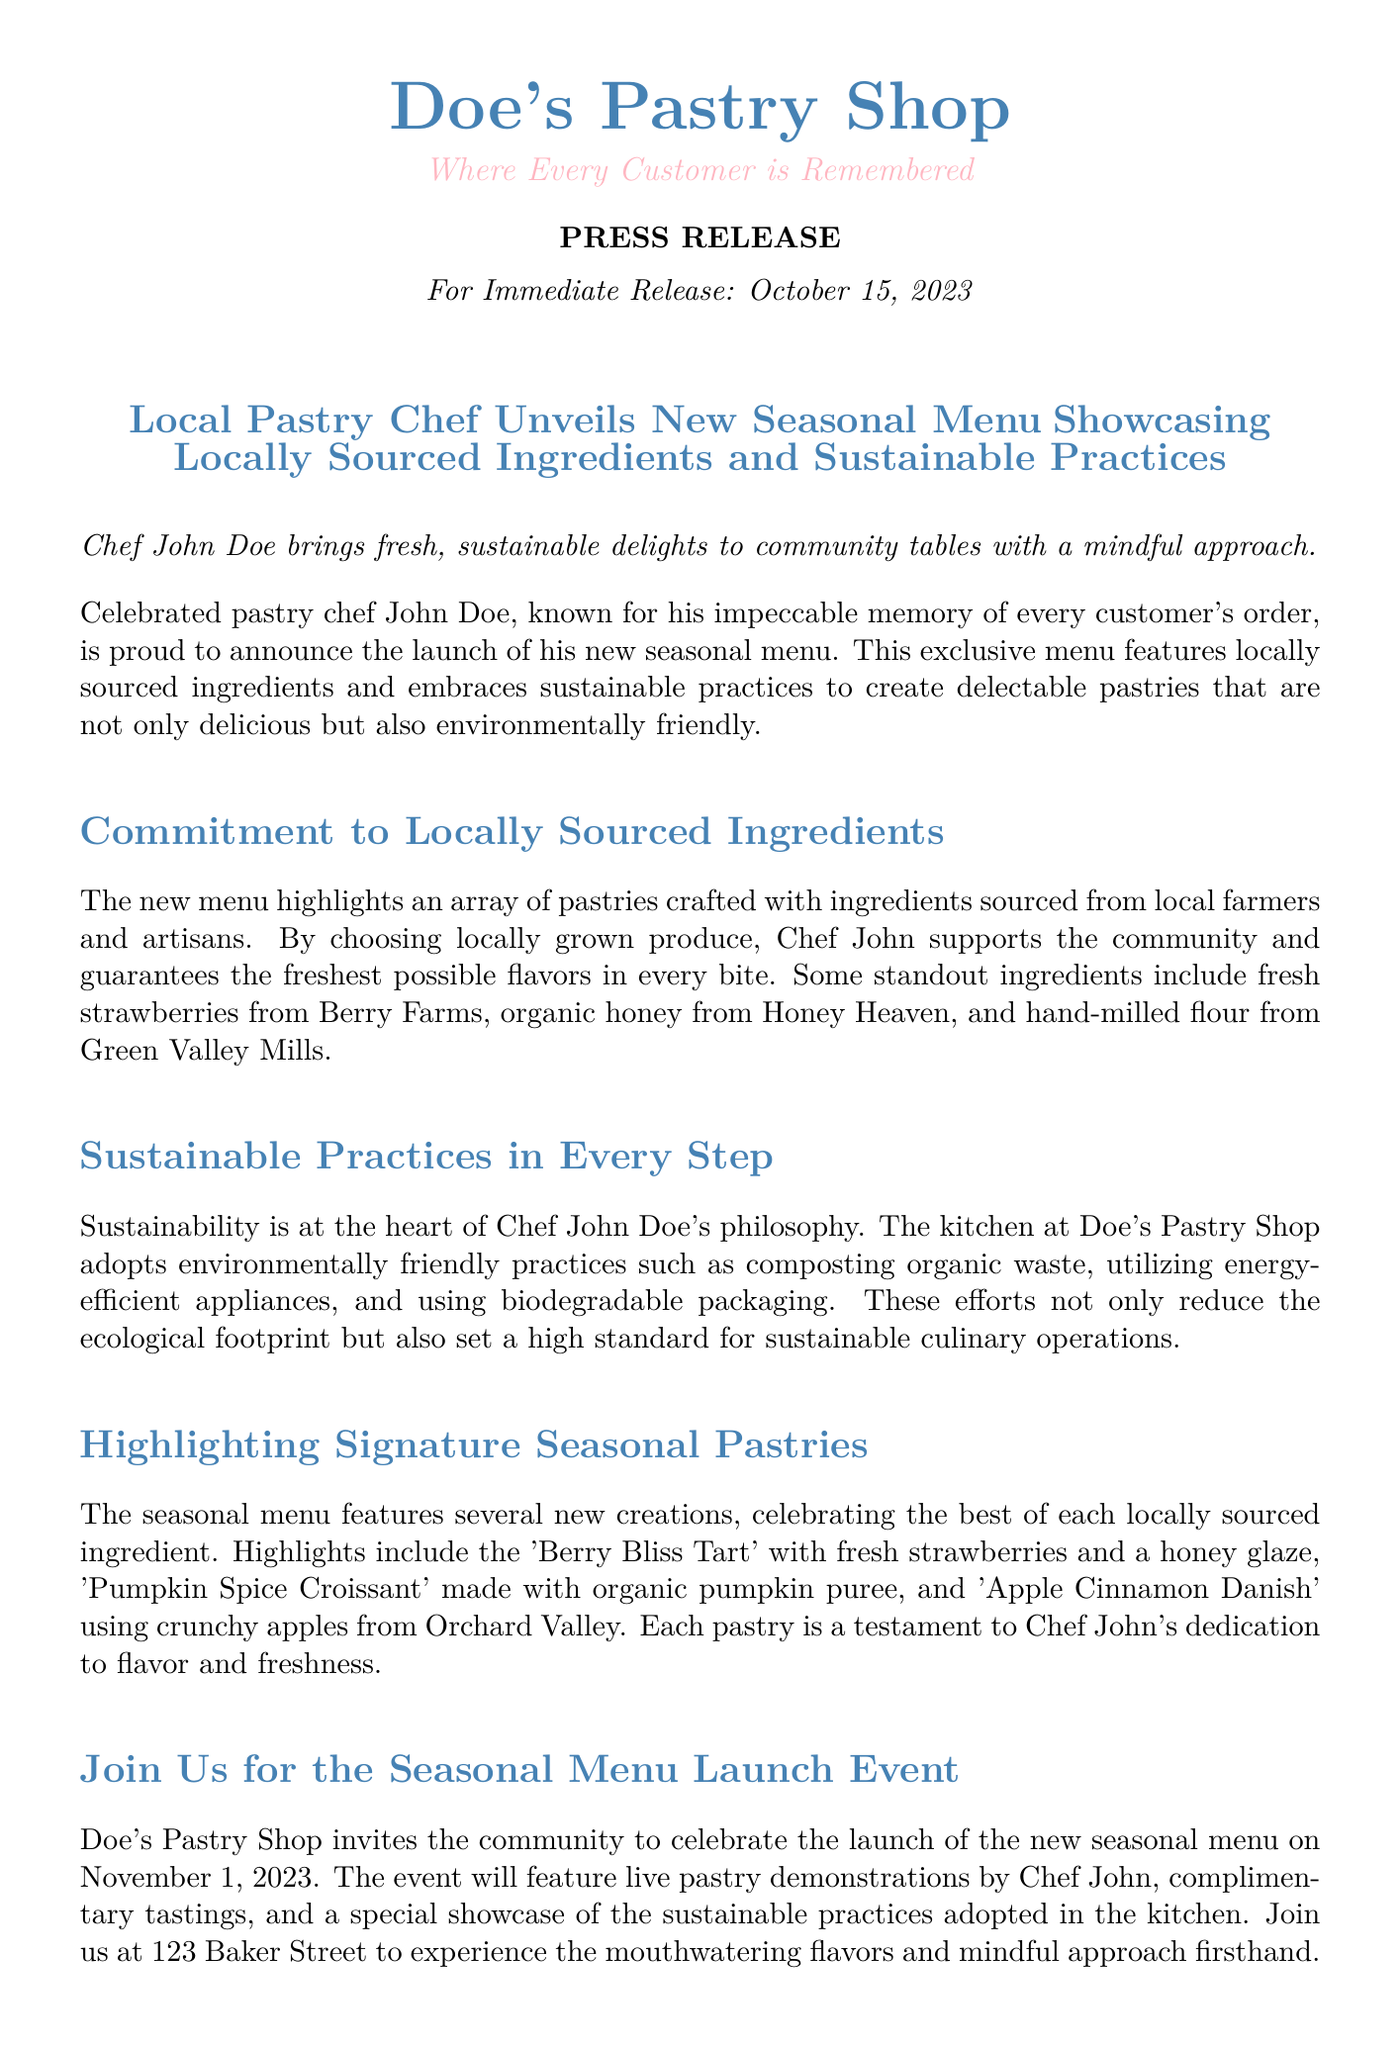What is the date of the press release? The date of the press release is stated at the beginning as “October 15, 2023.”
Answer: October 15, 2023 Who is the chef behind the new seasonal menu? The chef's name is mentioned in the document as “Chef John Doe.”
Answer: Chef John Doe What is the location of Doe's Pastry Shop? The address is found in the contact information section, stating “123 Baker Street, Sweet City.”
Answer: 123 Baker Street, Sweet City What is one of the sustainable practices adopted by the kitchen? The document lists “composting organic waste” as one sustainable practice among others.
Answer: composting organic waste What is the name of a pastry featuring fresh strawberries? The pastry highlighted in the document that uses fresh strawberries is the “Berry Bliss Tart.”
Answer: Berry Bliss Tart When is the seasonal menu launch event? The event date is specified in the document as “November 1, 2023.”
Answer: November 1, 2023 What type of ingredient is utilized from Honey Heaven? The document mentions “organic honey” sourced from Honey Heaven.
Answer: organic honey What is the key theme of the new seasonal menu? The theme revolves around using “locally sourced ingredients and sustainable practices.”
Answer: locally sourced ingredients and sustainable practices 